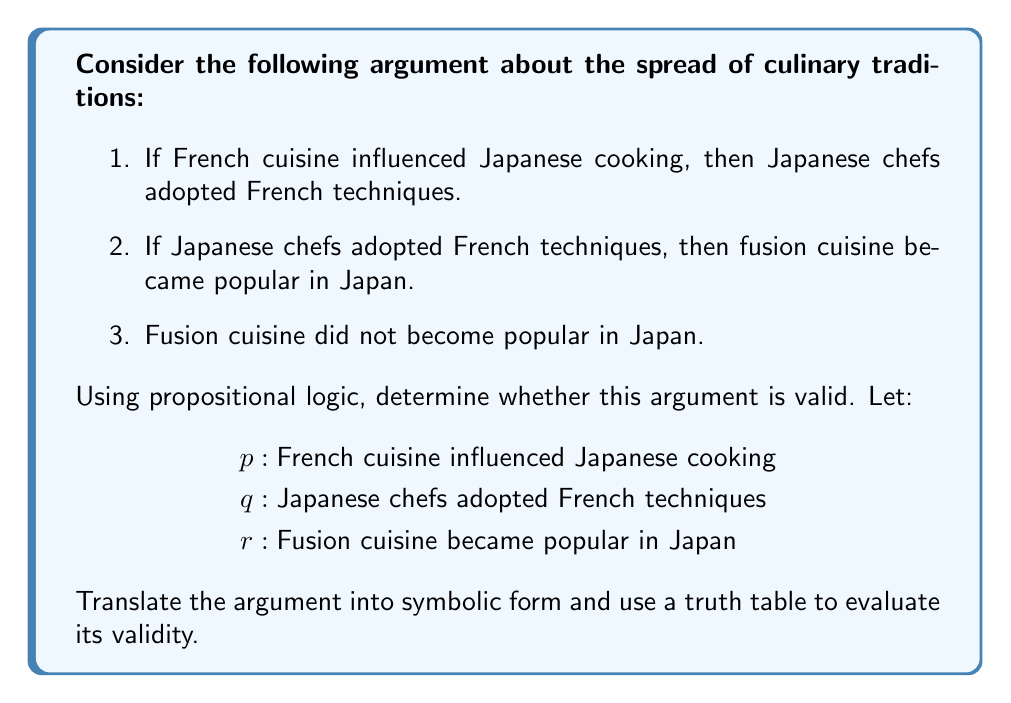What is the answer to this math problem? To determine the validity of this argument using propositional logic, we'll follow these steps:

1. Translate the argument into symbolic form:
   Premise 1: $p \rightarrow q$
   Premise 2: $q \rightarrow r$
   Premise 3: $\neg r$
   Conclusion: $\neg p$ (implied)

2. The argument structure is:
   $((p \rightarrow q) \land (q \rightarrow r) \land \neg r) \rightarrow \neg p$

3. To prove validity, we need to show that this statement is a tautology. We'll use a truth table:

   $$
   \begin{array}{ccc|ccccc}
   p & q & r & p \rightarrow q & q \rightarrow r & \neg r & ((p \rightarrow q) \land (q \rightarrow r) \land \neg r) & \neg p & \text{Result} \\
   \hline
   T & T & T & T & T & F & F & F & T \\
   T & T & F & T & F & T & F & F & T \\
   T & F & T & F & T & F & F & F & T \\
   T & F & F & F & T & T & F & F & T \\
   F & T & T & T & T & F & F & T & T \\
   F & T & F & T & F & T & F & T & T \\
   F & F & T & T & T & F & F & T & T \\
   F & F & F & T & T & T & T & T & T \\
   \end{array}
   $$

4. The last column shows that the statement is always true, regardless of the truth values of $p$, $q$, and $r$. This means it's a tautology.

5. Since the statement is a tautology, the argument is valid. In other words, if the premises are true, the conclusion must also be true.

This logical analysis demonstrates that if fusion cuisine did not become popular in Japan, then French cuisine could not have influenced Japanese cooking, given the premises of the argument.
Answer: The argument is valid. 